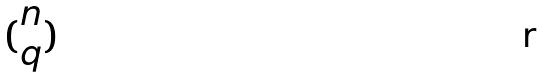<formula> <loc_0><loc_0><loc_500><loc_500>( \begin{matrix} n \\ q \end{matrix} )</formula> 